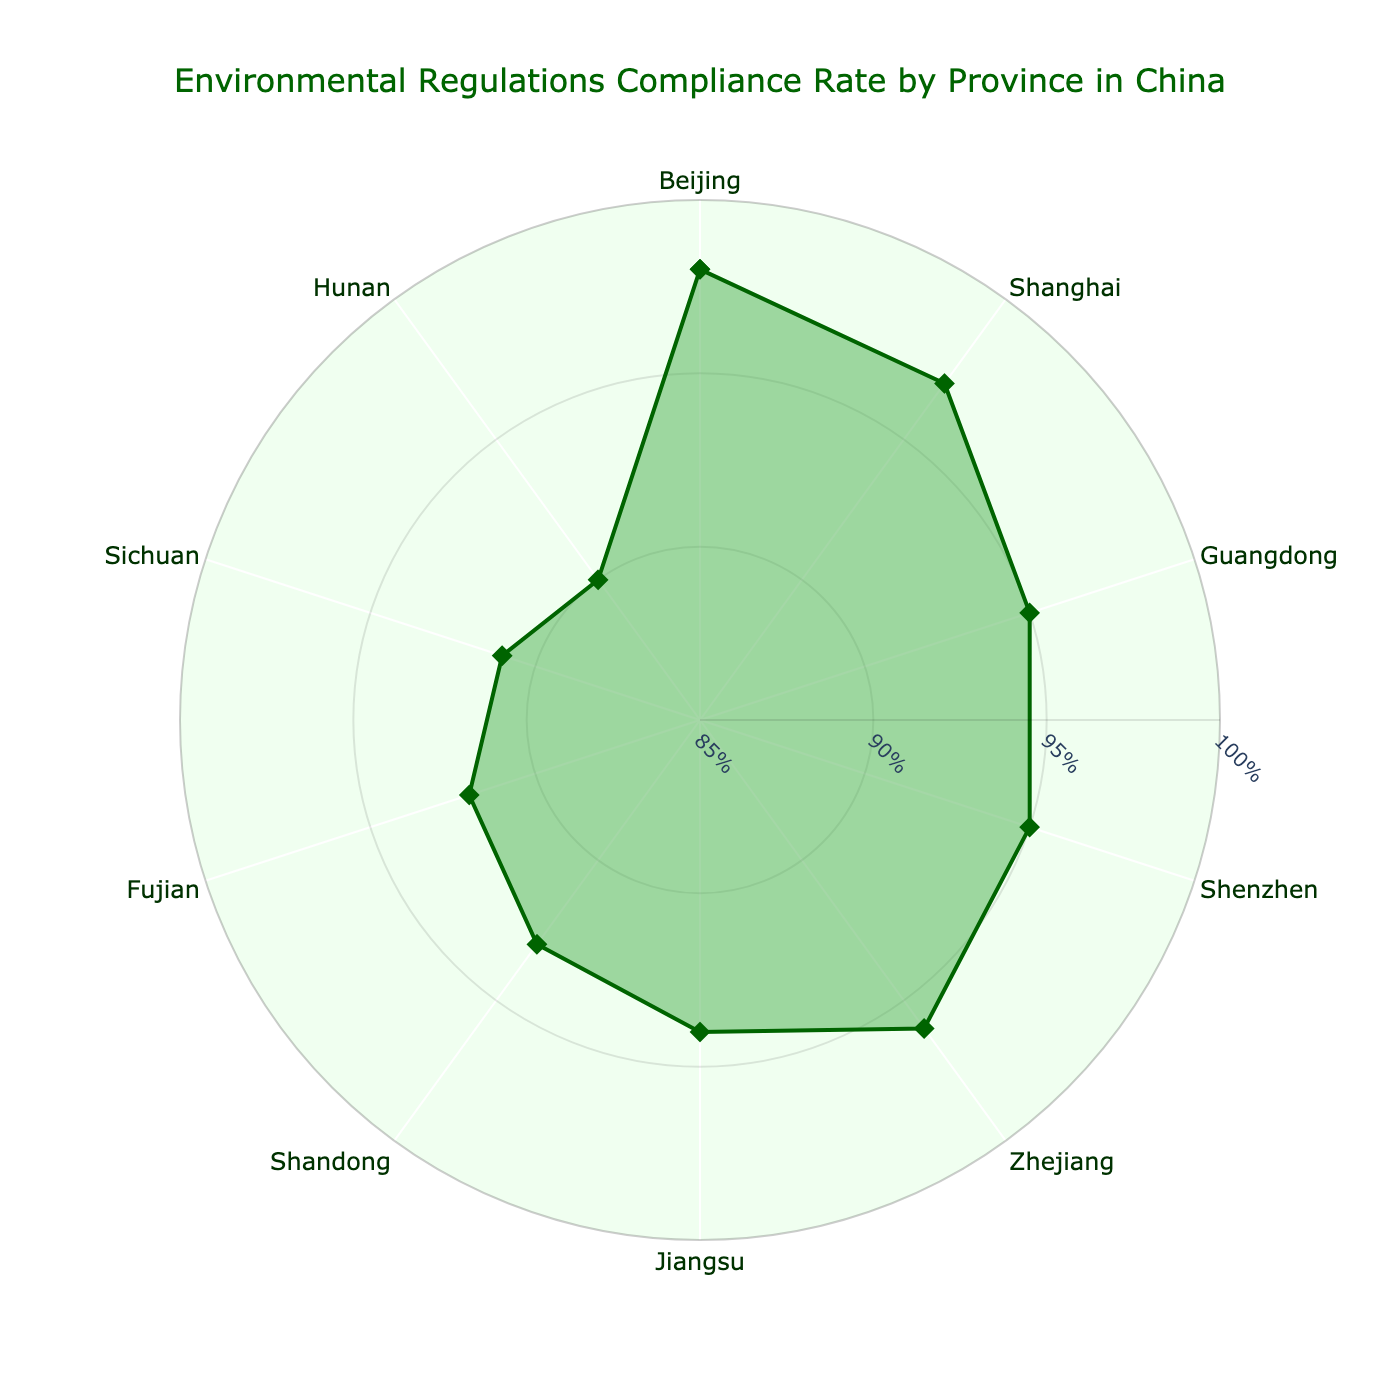What is the title of the radar chart? The title is positioned at the top of the chart and provides a summary of what the chart represents.
Answer: Environmental Regulations Compliance Rate by Province in China Which province has the highest compliance rate? The province with the highest point on the radial axis indicates the highest compliance rate.
Answer: Beijing How many provinces have compliance rates of 95% or higher? To count, identify the provinces with compliance points at or above the 95% threshold on the radar chart.
Answer: 4 (Beijing, Shanghai, Guangdong, Shenzhen) What is the average compliance rate across all listed provinces? Sum all compliance rates and divide by the number of provinces. (98 + 97 + 95 + 95 + 96 + 94 + 93 + 92 + 91 + 90) / 10 = 94.1
Answer: 94.1% Which province has the lowest compliance rate, and what is that rate? The province with the lowest point on the radial axis indicates the lowest compliance rate.
Answer: Hunan, 90% How does Jiangsu's compliance rate compare to Zhejiang's? Find the positions of Jiangsu and Zhejiang on the chart and compare their radial distances.
Answer: Jiangsu has a lower compliance rate than Zhejiang What is the difference in compliance rate between Shandong and Fujian? Subtract Fujian's compliance rate from Shandong's compliance rate. 93 - 92 = 1
Answer: 1% Which province's compliance rate is closest to the average compliance rate? Calculate the average compliance rate and find the province whose rate is closest to this average. Fujian: 92, as 94.1 - 92 = 2.1 which is the smallest difference.
Answer: Fujian Is Shanghai or Shenzhen more compliant with environmental regulations? Compare the radial distances of the two provinces on the chart.
Answer: Shanghai By how much does Sichuan's compliance rate exceed Hunan's? Subtract Hunan's compliance rate from Sichuan's compliance rate. 91 - 90 = 1
Answer: 1% 